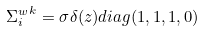<formula> <loc_0><loc_0><loc_500><loc_500>{ { \Sigma } ^ { w } _ { i } } ^ { k } = { \sigma } { \delta } ( z ) d i a g ( 1 , 1 , 1 , 0 )</formula> 